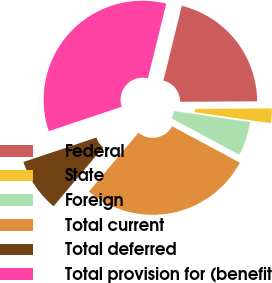<chart> <loc_0><loc_0><loc_500><loc_500><pie_chart><fcel>Federal<fcel>State<fcel>Foreign<fcel>Total current<fcel>Total deferred<fcel>Total provision for (benefit<nl><fcel>21.05%<fcel>2.4%<fcel>5.56%<fcel>28.28%<fcel>8.72%<fcel>33.99%<nl></chart> 